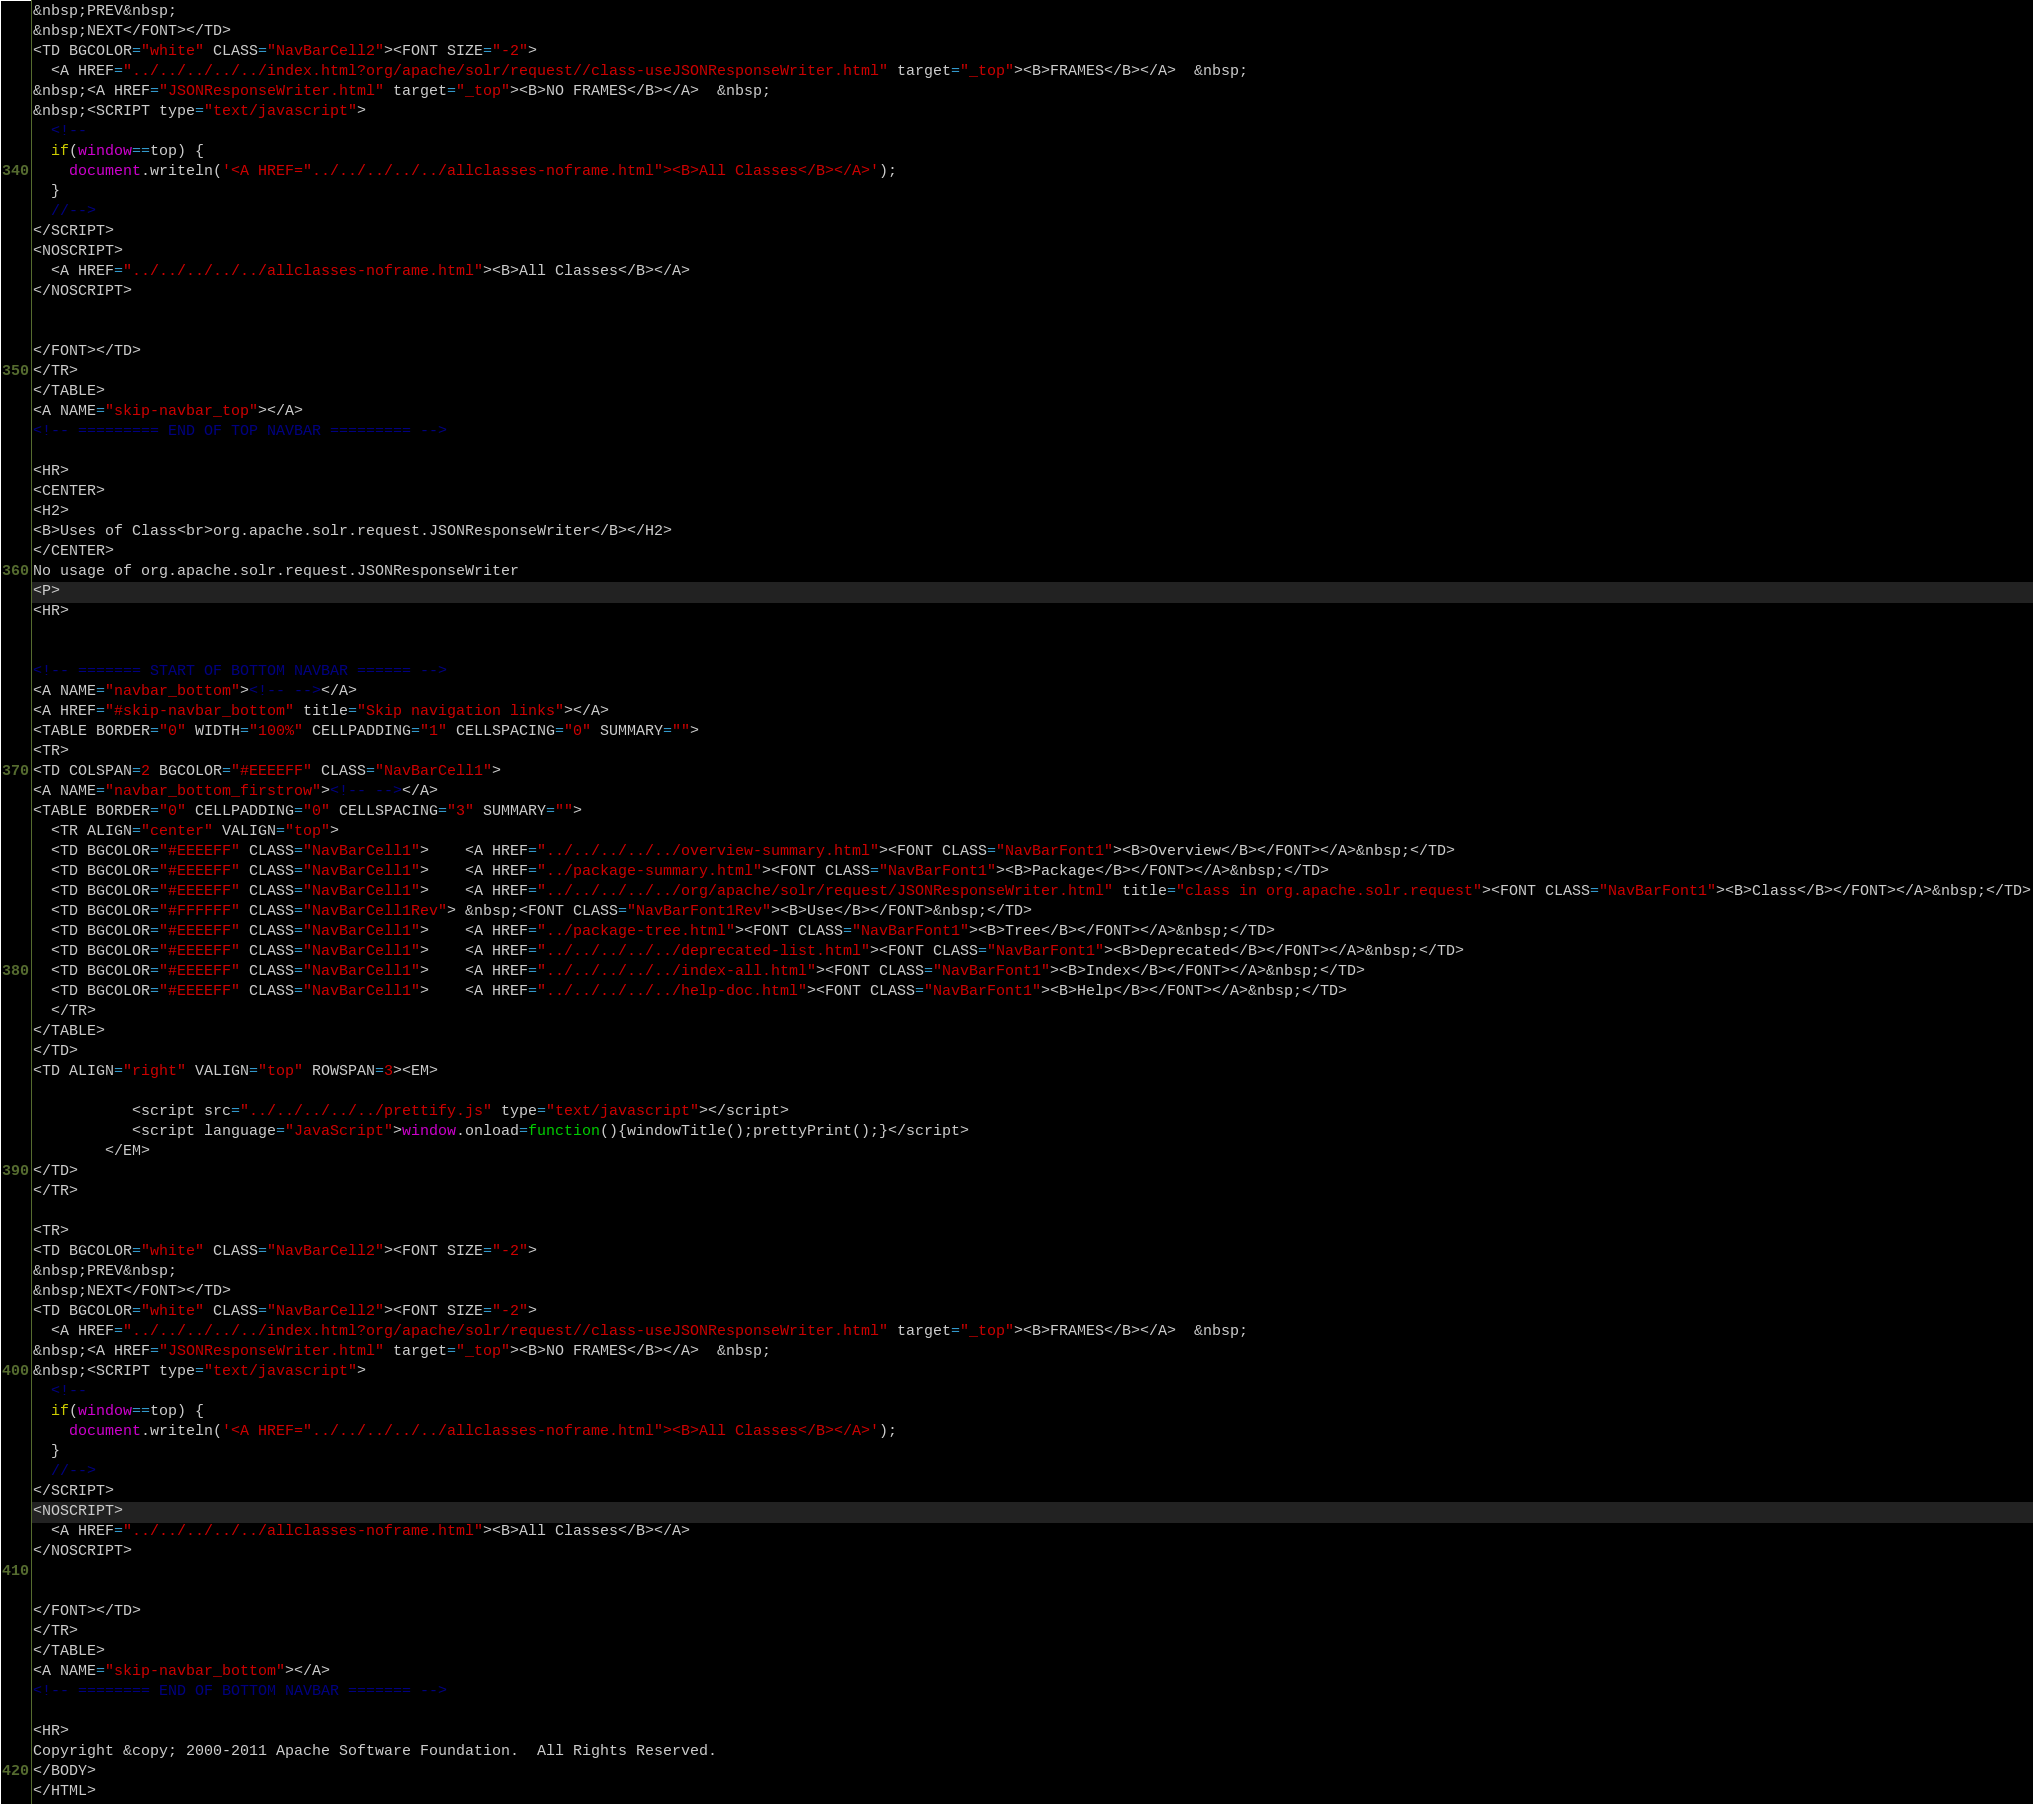Convert code to text. <code><loc_0><loc_0><loc_500><loc_500><_HTML_>&nbsp;PREV&nbsp;
&nbsp;NEXT</FONT></TD>
<TD BGCOLOR="white" CLASS="NavBarCell2"><FONT SIZE="-2">
  <A HREF="../../../../../index.html?org/apache/solr/request//class-useJSONResponseWriter.html" target="_top"><B>FRAMES</B></A>  &nbsp;
&nbsp;<A HREF="JSONResponseWriter.html" target="_top"><B>NO FRAMES</B></A>  &nbsp;
&nbsp;<SCRIPT type="text/javascript">
  <!--
  if(window==top) {
    document.writeln('<A HREF="../../../../../allclasses-noframe.html"><B>All Classes</B></A>');
  }
  //-->
</SCRIPT>
<NOSCRIPT>
  <A HREF="../../../../../allclasses-noframe.html"><B>All Classes</B></A>
</NOSCRIPT>


</FONT></TD>
</TR>
</TABLE>
<A NAME="skip-navbar_top"></A>
<!-- ========= END OF TOP NAVBAR ========= -->

<HR>
<CENTER>
<H2>
<B>Uses of Class<br>org.apache.solr.request.JSONResponseWriter</B></H2>
</CENTER>
No usage of org.apache.solr.request.JSONResponseWriter
<P>
<HR>


<!-- ======= START OF BOTTOM NAVBAR ====== -->
<A NAME="navbar_bottom"><!-- --></A>
<A HREF="#skip-navbar_bottom" title="Skip navigation links"></A>
<TABLE BORDER="0" WIDTH="100%" CELLPADDING="1" CELLSPACING="0" SUMMARY="">
<TR>
<TD COLSPAN=2 BGCOLOR="#EEEEFF" CLASS="NavBarCell1">
<A NAME="navbar_bottom_firstrow"><!-- --></A>
<TABLE BORDER="0" CELLPADDING="0" CELLSPACING="3" SUMMARY="">
  <TR ALIGN="center" VALIGN="top">
  <TD BGCOLOR="#EEEEFF" CLASS="NavBarCell1">    <A HREF="../../../../../overview-summary.html"><FONT CLASS="NavBarFont1"><B>Overview</B></FONT></A>&nbsp;</TD>
  <TD BGCOLOR="#EEEEFF" CLASS="NavBarCell1">    <A HREF="../package-summary.html"><FONT CLASS="NavBarFont1"><B>Package</B></FONT></A>&nbsp;</TD>
  <TD BGCOLOR="#EEEEFF" CLASS="NavBarCell1">    <A HREF="../../../../../org/apache/solr/request/JSONResponseWriter.html" title="class in org.apache.solr.request"><FONT CLASS="NavBarFont1"><B>Class</B></FONT></A>&nbsp;</TD>
  <TD BGCOLOR="#FFFFFF" CLASS="NavBarCell1Rev"> &nbsp;<FONT CLASS="NavBarFont1Rev"><B>Use</B></FONT>&nbsp;</TD>
  <TD BGCOLOR="#EEEEFF" CLASS="NavBarCell1">    <A HREF="../package-tree.html"><FONT CLASS="NavBarFont1"><B>Tree</B></FONT></A>&nbsp;</TD>
  <TD BGCOLOR="#EEEEFF" CLASS="NavBarCell1">    <A HREF="../../../../../deprecated-list.html"><FONT CLASS="NavBarFont1"><B>Deprecated</B></FONT></A>&nbsp;</TD>
  <TD BGCOLOR="#EEEEFF" CLASS="NavBarCell1">    <A HREF="../../../../../index-all.html"><FONT CLASS="NavBarFont1"><B>Index</B></FONT></A>&nbsp;</TD>
  <TD BGCOLOR="#EEEEFF" CLASS="NavBarCell1">    <A HREF="../../../../../help-doc.html"><FONT CLASS="NavBarFont1"><B>Help</B></FONT></A>&nbsp;</TD>
  </TR>
</TABLE>
</TD>
<TD ALIGN="right" VALIGN="top" ROWSPAN=3><EM>

           <script src="../../../../../prettify.js" type="text/javascript"></script>
           <script language="JavaScript">window.onload=function(){windowTitle();prettyPrint();}</script>
        </EM>
</TD>
</TR>

<TR>
<TD BGCOLOR="white" CLASS="NavBarCell2"><FONT SIZE="-2">
&nbsp;PREV&nbsp;
&nbsp;NEXT</FONT></TD>
<TD BGCOLOR="white" CLASS="NavBarCell2"><FONT SIZE="-2">
  <A HREF="../../../../../index.html?org/apache/solr/request//class-useJSONResponseWriter.html" target="_top"><B>FRAMES</B></A>  &nbsp;
&nbsp;<A HREF="JSONResponseWriter.html" target="_top"><B>NO FRAMES</B></A>  &nbsp;
&nbsp;<SCRIPT type="text/javascript">
  <!--
  if(window==top) {
    document.writeln('<A HREF="../../../../../allclasses-noframe.html"><B>All Classes</B></A>');
  }
  //-->
</SCRIPT>
<NOSCRIPT>
  <A HREF="../../../../../allclasses-noframe.html"><B>All Classes</B></A>
</NOSCRIPT>


</FONT></TD>
</TR>
</TABLE>
<A NAME="skip-navbar_bottom"></A>
<!-- ======== END OF BOTTOM NAVBAR ======= -->

<HR>
Copyright &copy; 2000-2011 Apache Software Foundation.  All Rights Reserved.
</BODY>
</HTML>
</code> 